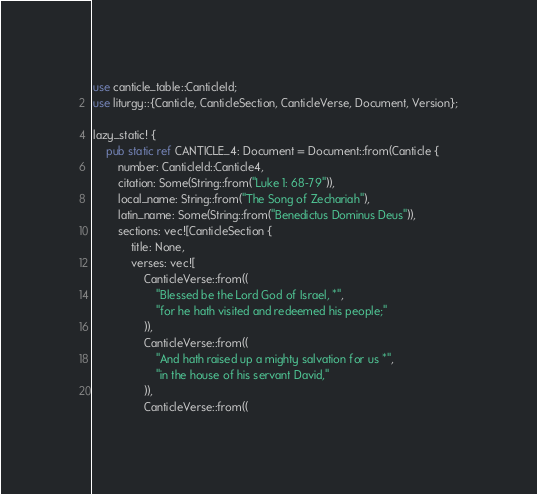<code> <loc_0><loc_0><loc_500><loc_500><_Rust_>use canticle_table::CanticleId;
use liturgy::{Canticle, CanticleSection, CanticleVerse, Document, Version};

lazy_static! {
    pub static ref CANTICLE_4: Document = Document::from(Canticle {
        number: CanticleId::Canticle4,
        citation: Some(String::from("Luke 1: 68-79")),
        local_name: String::from("The Song of Zechariah"),
        latin_name: Some(String::from("Benedictus Dominus Deus")),
        sections: vec![CanticleSection {
            title: None,
            verses: vec![
                CanticleVerse::from((
                    "Blessed be the Lord God of Israel, *",
                    "for he hath visited and redeemed his people;"
                )),
                CanticleVerse::from((
                    "And hath raised up a mighty salvation for us *",
                    "in the house of his servant David,"
                )),
                CanticleVerse::from((</code> 